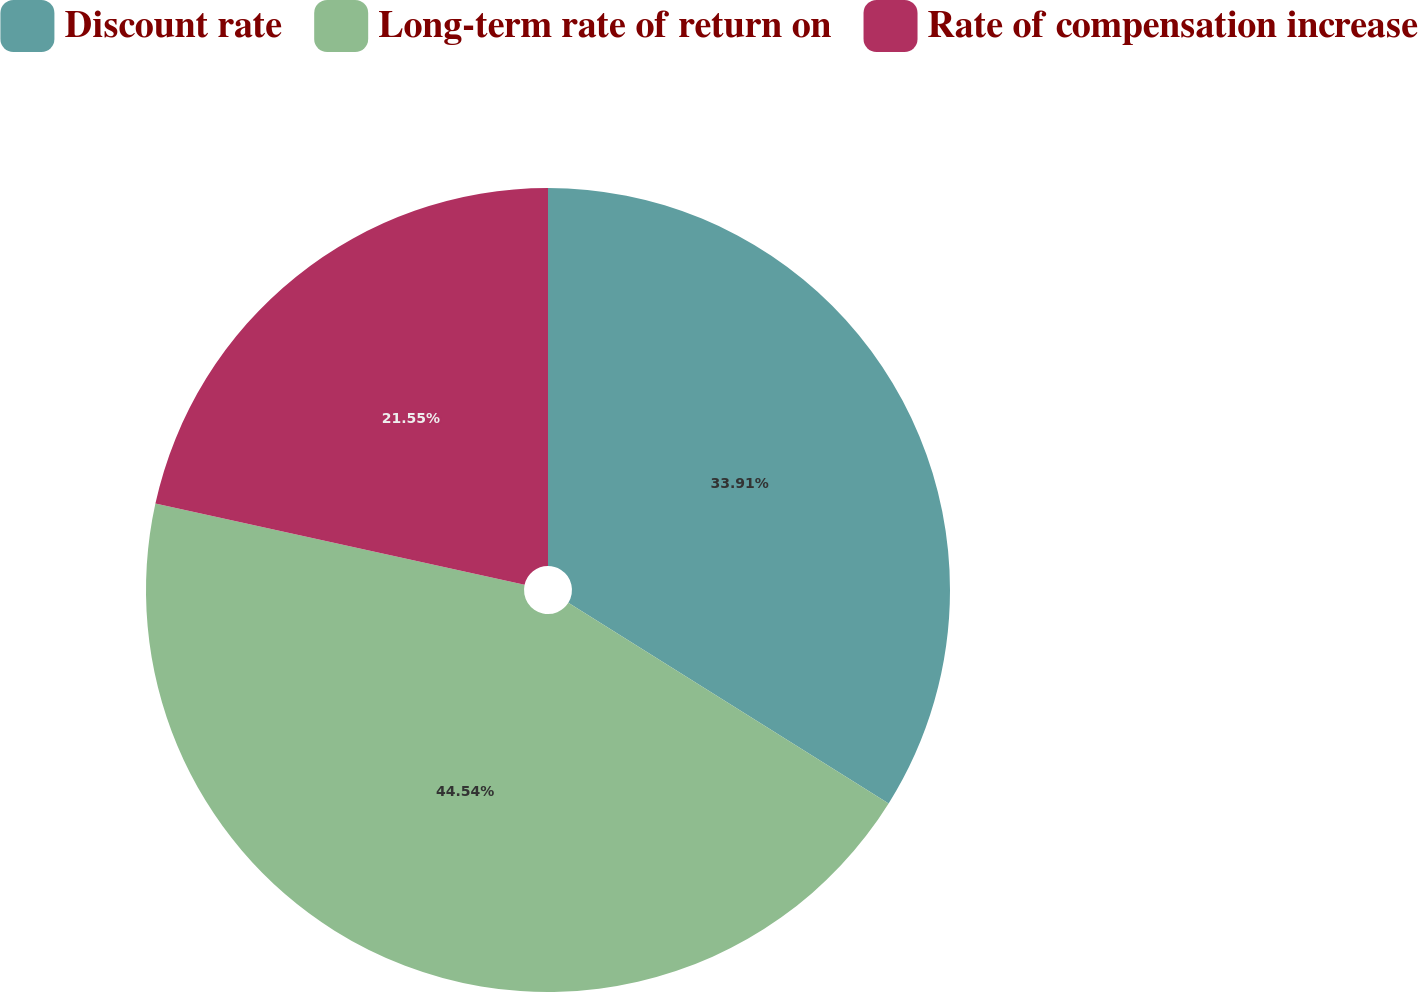Convert chart. <chart><loc_0><loc_0><loc_500><loc_500><pie_chart><fcel>Discount rate<fcel>Long-term rate of return on<fcel>Rate of compensation increase<nl><fcel>33.91%<fcel>44.54%<fcel>21.55%<nl></chart> 